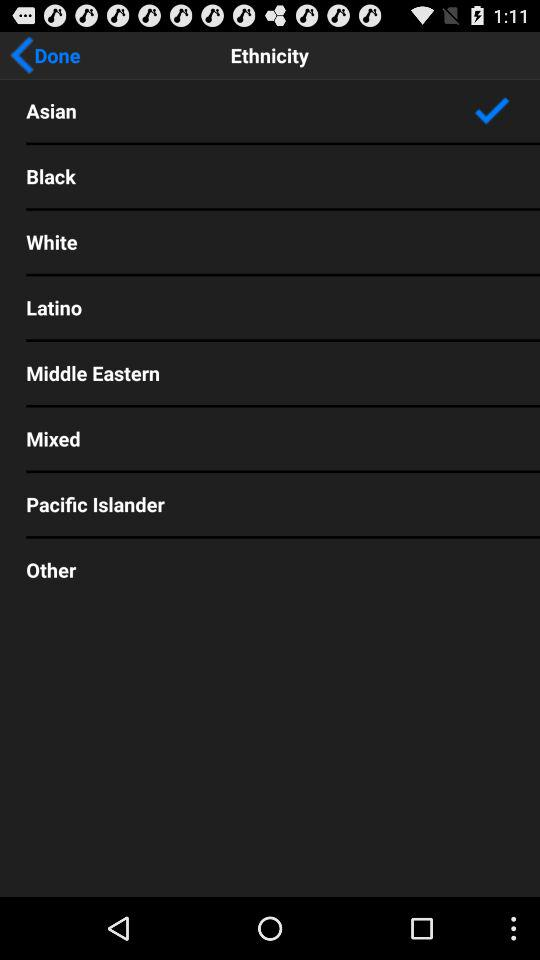Which ethnicity is selected? The selected ethnicity is "Asian". 